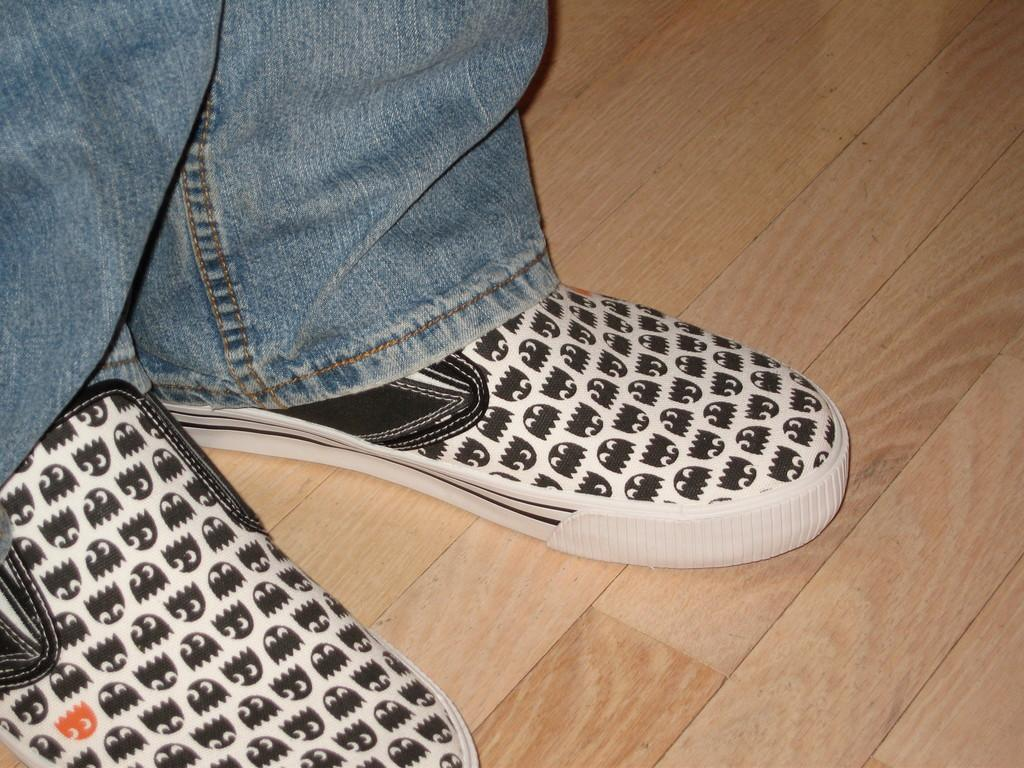What is the main subject of the image? There is a person in the image. What type of clothing is the person wearing? The person is wearing blue jeans. What type of footwear is the person wearing? The person is wearing shoes. What surface is the person standing on? The person is standing on the floor. What is the person's reaction to the ongoing competition in the image? There is no competition present in the image, so it is not possible to determine the person's reaction to it. 